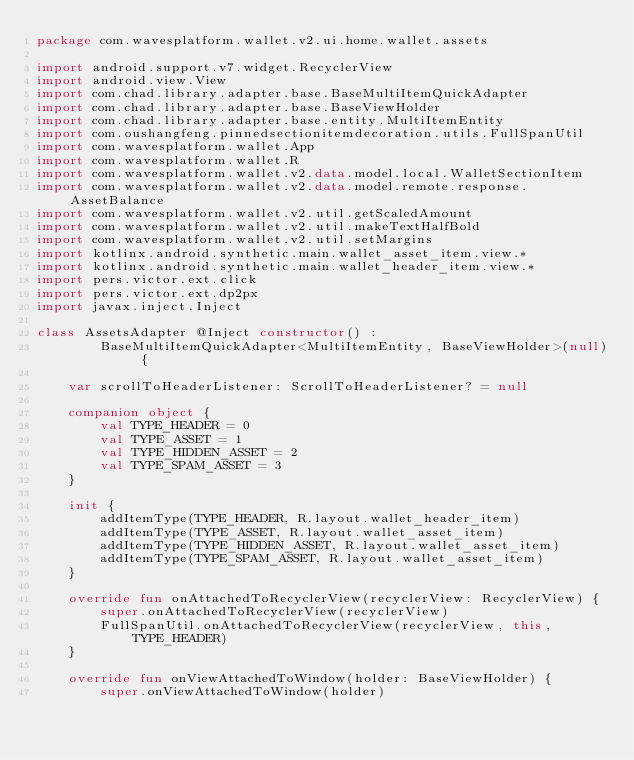Convert code to text. <code><loc_0><loc_0><loc_500><loc_500><_Kotlin_>package com.wavesplatform.wallet.v2.ui.home.wallet.assets

import android.support.v7.widget.RecyclerView
import android.view.View
import com.chad.library.adapter.base.BaseMultiItemQuickAdapter
import com.chad.library.adapter.base.BaseViewHolder
import com.chad.library.adapter.base.entity.MultiItemEntity
import com.oushangfeng.pinnedsectionitemdecoration.utils.FullSpanUtil
import com.wavesplatform.wallet.App
import com.wavesplatform.wallet.R
import com.wavesplatform.wallet.v2.data.model.local.WalletSectionItem
import com.wavesplatform.wallet.v2.data.model.remote.response.AssetBalance
import com.wavesplatform.wallet.v2.util.getScaledAmount
import com.wavesplatform.wallet.v2.util.makeTextHalfBold
import com.wavesplatform.wallet.v2.util.setMargins
import kotlinx.android.synthetic.main.wallet_asset_item.view.*
import kotlinx.android.synthetic.main.wallet_header_item.view.*
import pers.victor.ext.click
import pers.victor.ext.dp2px
import javax.inject.Inject

class AssetsAdapter @Inject constructor() :
        BaseMultiItemQuickAdapter<MultiItemEntity, BaseViewHolder>(null) {

    var scrollToHeaderListener: ScrollToHeaderListener? = null

    companion object {
        val TYPE_HEADER = 0
        val TYPE_ASSET = 1
        val TYPE_HIDDEN_ASSET = 2
        val TYPE_SPAM_ASSET = 3
    }

    init {
        addItemType(TYPE_HEADER, R.layout.wallet_header_item)
        addItemType(TYPE_ASSET, R.layout.wallet_asset_item)
        addItemType(TYPE_HIDDEN_ASSET, R.layout.wallet_asset_item)
        addItemType(TYPE_SPAM_ASSET, R.layout.wallet_asset_item)
    }

    override fun onAttachedToRecyclerView(recyclerView: RecyclerView) {
        super.onAttachedToRecyclerView(recyclerView)
        FullSpanUtil.onAttachedToRecyclerView(recyclerView, this, TYPE_HEADER)
    }

    override fun onViewAttachedToWindow(holder: BaseViewHolder) {
        super.onViewAttachedToWindow(holder)</code> 